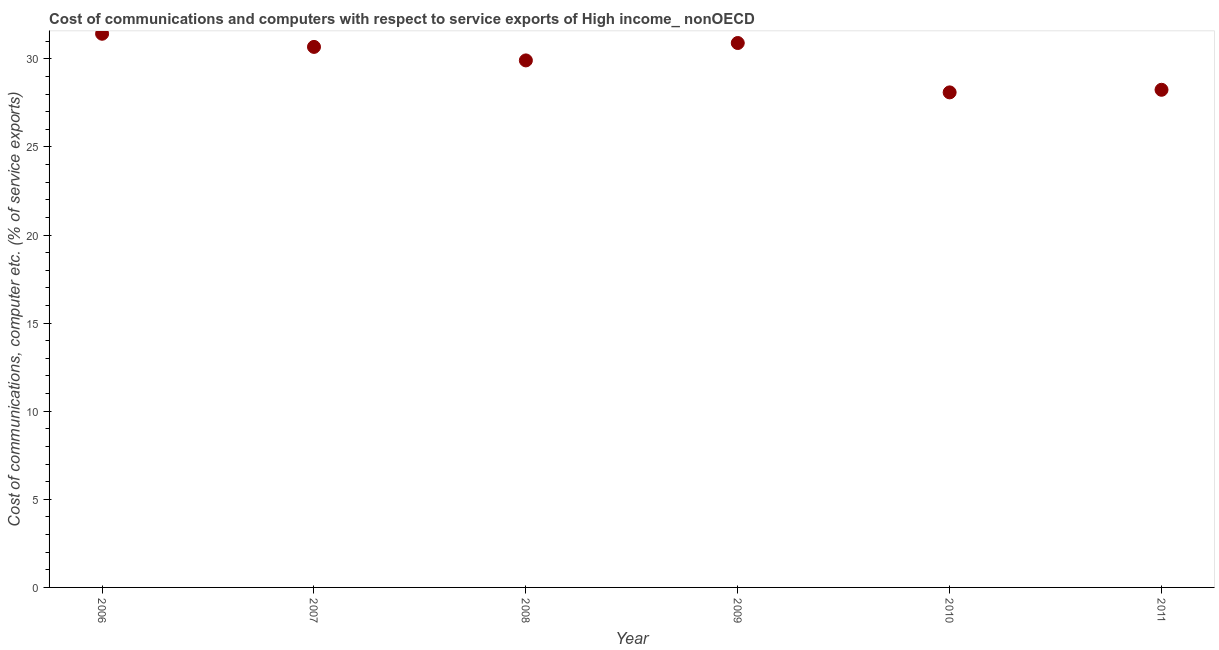What is the cost of communications and computer in 2006?
Offer a terse response. 31.42. Across all years, what is the maximum cost of communications and computer?
Make the answer very short. 31.42. Across all years, what is the minimum cost of communications and computer?
Give a very brief answer. 28.09. What is the sum of the cost of communications and computer?
Offer a very short reply. 179.24. What is the difference between the cost of communications and computer in 2009 and 2010?
Your answer should be very brief. 2.8. What is the average cost of communications and computer per year?
Offer a very short reply. 29.87. What is the median cost of communications and computer?
Keep it short and to the point. 30.29. Do a majority of the years between 2007 and 2006 (inclusive) have cost of communications and computer greater than 9 %?
Your answer should be compact. No. What is the ratio of the cost of communications and computer in 2009 to that in 2010?
Ensure brevity in your answer.  1.1. Is the cost of communications and computer in 2008 less than that in 2009?
Keep it short and to the point. Yes. What is the difference between the highest and the second highest cost of communications and computer?
Offer a terse response. 0.53. Is the sum of the cost of communications and computer in 2008 and 2009 greater than the maximum cost of communications and computer across all years?
Keep it short and to the point. Yes. What is the difference between the highest and the lowest cost of communications and computer?
Provide a short and direct response. 3.33. In how many years, is the cost of communications and computer greater than the average cost of communications and computer taken over all years?
Keep it short and to the point. 4. Does the cost of communications and computer monotonically increase over the years?
Give a very brief answer. No. How many dotlines are there?
Offer a very short reply. 1. Does the graph contain any zero values?
Ensure brevity in your answer.  No. What is the title of the graph?
Your response must be concise. Cost of communications and computers with respect to service exports of High income_ nonOECD. What is the label or title of the X-axis?
Your response must be concise. Year. What is the label or title of the Y-axis?
Offer a terse response. Cost of communications, computer etc. (% of service exports). What is the Cost of communications, computer etc. (% of service exports) in 2006?
Offer a terse response. 31.42. What is the Cost of communications, computer etc. (% of service exports) in 2007?
Offer a terse response. 30.68. What is the Cost of communications, computer etc. (% of service exports) in 2008?
Give a very brief answer. 29.91. What is the Cost of communications, computer etc. (% of service exports) in 2009?
Your answer should be very brief. 30.9. What is the Cost of communications, computer etc. (% of service exports) in 2010?
Keep it short and to the point. 28.09. What is the Cost of communications, computer etc. (% of service exports) in 2011?
Ensure brevity in your answer.  28.24. What is the difference between the Cost of communications, computer etc. (% of service exports) in 2006 and 2007?
Your response must be concise. 0.75. What is the difference between the Cost of communications, computer etc. (% of service exports) in 2006 and 2008?
Make the answer very short. 1.51. What is the difference between the Cost of communications, computer etc. (% of service exports) in 2006 and 2009?
Offer a very short reply. 0.53. What is the difference between the Cost of communications, computer etc. (% of service exports) in 2006 and 2010?
Offer a terse response. 3.33. What is the difference between the Cost of communications, computer etc. (% of service exports) in 2006 and 2011?
Offer a terse response. 3.18. What is the difference between the Cost of communications, computer etc. (% of service exports) in 2007 and 2008?
Offer a very short reply. 0.77. What is the difference between the Cost of communications, computer etc. (% of service exports) in 2007 and 2009?
Your answer should be compact. -0.22. What is the difference between the Cost of communications, computer etc. (% of service exports) in 2007 and 2010?
Keep it short and to the point. 2.58. What is the difference between the Cost of communications, computer etc. (% of service exports) in 2007 and 2011?
Provide a succinct answer. 2.43. What is the difference between the Cost of communications, computer etc. (% of service exports) in 2008 and 2009?
Provide a short and direct response. -0.99. What is the difference between the Cost of communications, computer etc. (% of service exports) in 2008 and 2010?
Offer a very short reply. 1.81. What is the difference between the Cost of communications, computer etc. (% of service exports) in 2008 and 2011?
Offer a terse response. 1.67. What is the difference between the Cost of communications, computer etc. (% of service exports) in 2009 and 2010?
Offer a terse response. 2.8. What is the difference between the Cost of communications, computer etc. (% of service exports) in 2009 and 2011?
Provide a short and direct response. 2.65. What is the difference between the Cost of communications, computer etc. (% of service exports) in 2010 and 2011?
Provide a succinct answer. -0.15. What is the ratio of the Cost of communications, computer etc. (% of service exports) in 2006 to that in 2007?
Ensure brevity in your answer.  1.02. What is the ratio of the Cost of communications, computer etc. (% of service exports) in 2006 to that in 2008?
Your response must be concise. 1.05. What is the ratio of the Cost of communications, computer etc. (% of service exports) in 2006 to that in 2010?
Ensure brevity in your answer.  1.12. What is the ratio of the Cost of communications, computer etc. (% of service exports) in 2006 to that in 2011?
Ensure brevity in your answer.  1.11. What is the ratio of the Cost of communications, computer etc. (% of service exports) in 2007 to that in 2009?
Your answer should be compact. 0.99. What is the ratio of the Cost of communications, computer etc. (% of service exports) in 2007 to that in 2010?
Your answer should be compact. 1.09. What is the ratio of the Cost of communications, computer etc. (% of service exports) in 2007 to that in 2011?
Ensure brevity in your answer.  1.09. What is the ratio of the Cost of communications, computer etc. (% of service exports) in 2008 to that in 2010?
Ensure brevity in your answer.  1.06. What is the ratio of the Cost of communications, computer etc. (% of service exports) in 2008 to that in 2011?
Offer a terse response. 1.06. What is the ratio of the Cost of communications, computer etc. (% of service exports) in 2009 to that in 2010?
Your answer should be very brief. 1.1. What is the ratio of the Cost of communications, computer etc. (% of service exports) in 2009 to that in 2011?
Make the answer very short. 1.09. What is the ratio of the Cost of communications, computer etc. (% of service exports) in 2010 to that in 2011?
Provide a succinct answer. 0.99. 